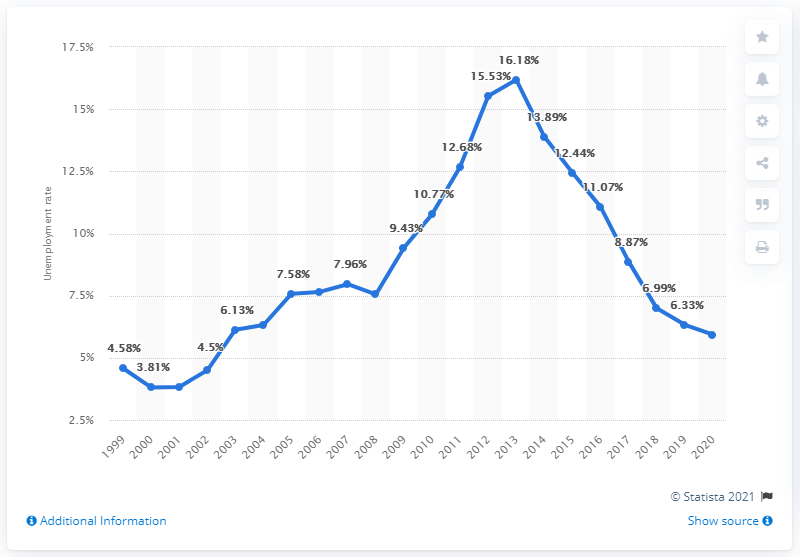Draw attention to some important aspects in this diagram. In 2020, the unemployment rate in Portugal was 5.93%. 